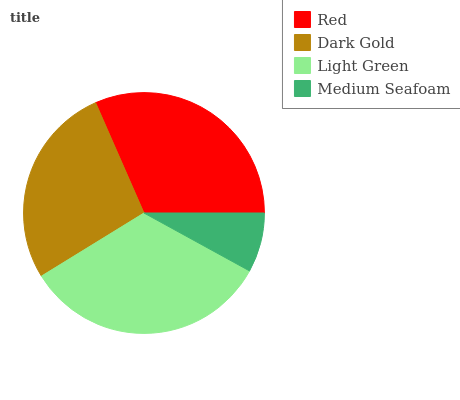Is Medium Seafoam the minimum?
Answer yes or no. Yes. Is Light Green the maximum?
Answer yes or no. Yes. Is Dark Gold the minimum?
Answer yes or no. No. Is Dark Gold the maximum?
Answer yes or no. No. Is Red greater than Dark Gold?
Answer yes or no. Yes. Is Dark Gold less than Red?
Answer yes or no. Yes. Is Dark Gold greater than Red?
Answer yes or no. No. Is Red less than Dark Gold?
Answer yes or no. No. Is Red the high median?
Answer yes or no. Yes. Is Dark Gold the low median?
Answer yes or no. Yes. Is Light Green the high median?
Answer yes or no. No. Is Red the low median?
Answer yes or no. No. 